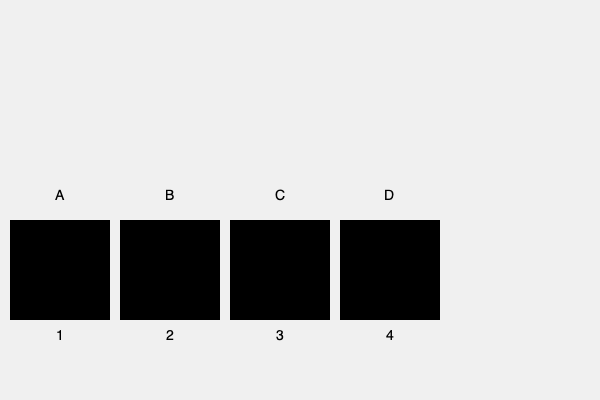Match the silhouettes (1-4) of the speedster characters to their corresponding full-color images (A-D) from The Flash TV series. Provide your answer as a sequence of four letters corresponding to the numbers 1-4. To match the silhouettes to the full-color images, follow these steps:

1. Analyze the distinctive features of each speedster's costume in the full-color images:
   A: The Flash - streamlined suit with lightning bolt emblem
   B: Kid Flash - similar to Flash, but with open top and different color scheme
   C: Reverse-Flash - inverted color scheme of Flash, with red lightning bolt
   D: Zoom - dark suit with blue lightning accents

2. Compare these features to the silhouettes:
   1: Matches the streamlined look of The Flash (A)
   2: Shows the open top design of Kid Flash (B)
   3: Has the distinctive pointed ears of Zoom's mask (D)
   4: Displays the similar but slightly different silhouette of Reverse-Flash (C)

3. Based on these comparisons, we can match the silhouettes to the images:
   1 - A (The Flash)
   2 - B (Kid Flash)
   3 - D (Zoom)
   4 - C (Reverse-Flash)

4. Arrange the letters in the order of the numbers to get the final answer.
Answer: ABDC 